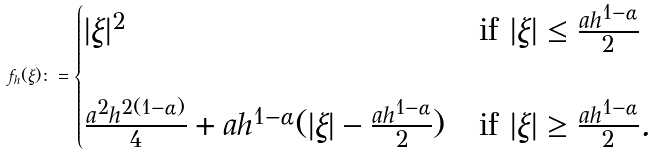Convert formula to latex. <formula><loc_0><loc_0><loc_500><loc_500>f _ { h } ( \xi ) \colon = \begin{cases} | \xi | ^ { 2 } & \text {if } | \xi | \leq \frac { a h ^ { 1 - \alpha } } { 2 } \\ \\ \frac { a ^ { 2 } h ^ { 2 ( 1 - \alpha ) } } { 4 } + a h ^ { 1 - \alpha } ( | \xi | - \frac { a h ^ { 1 - \alpha } } { 2 } ) & \text {if } | \xi | \geq \frac { a h ^ { 1 - \alpha } } { 2 } . \end{cases}</formula> 